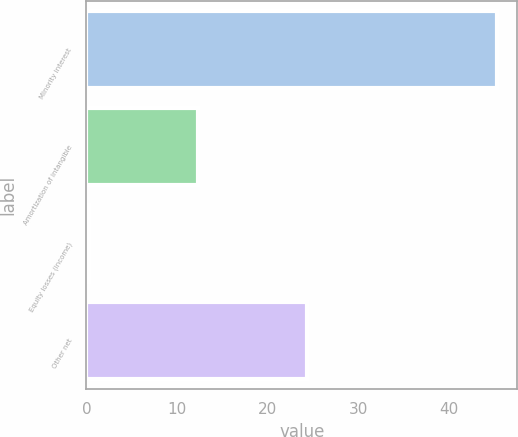Convert chart to OTSL. <chart><loc_0><loc_0><loc_500><loc_500><bar_chart><fcel>Minority interest<fcel>Amortization of intangible<fcel>Equity losses (income)<fcel>Other net<nl><fcel>45.2<fcel>12.3<fcel>0.3<fcel>24.3<nl></chart> 